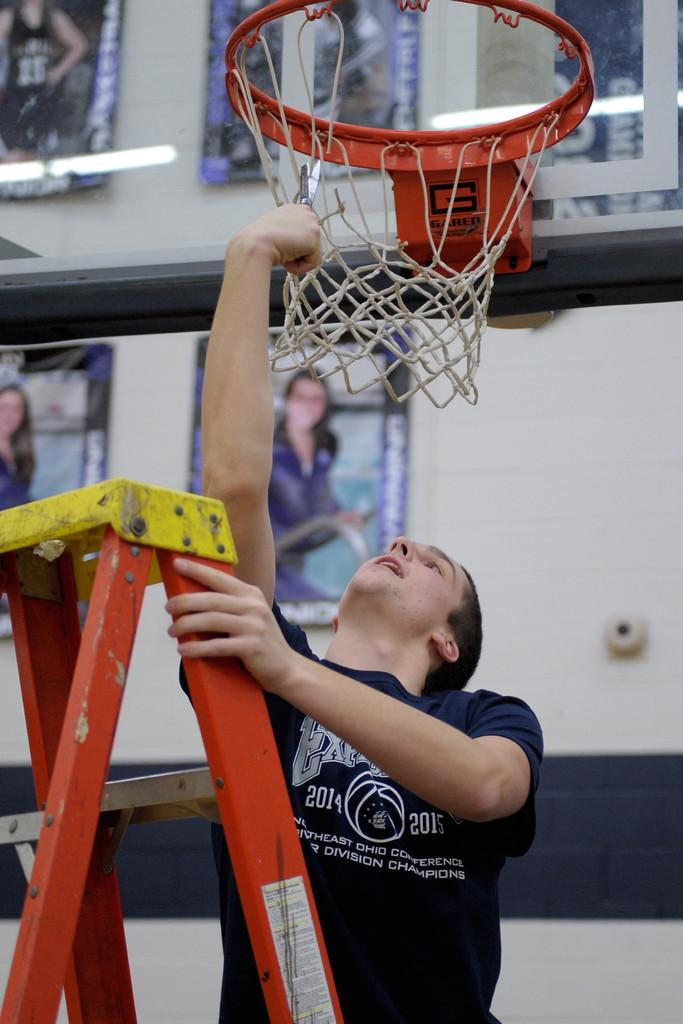<image>
Provide a brief description of the given image. a person with a shirt that says 2014 on it 